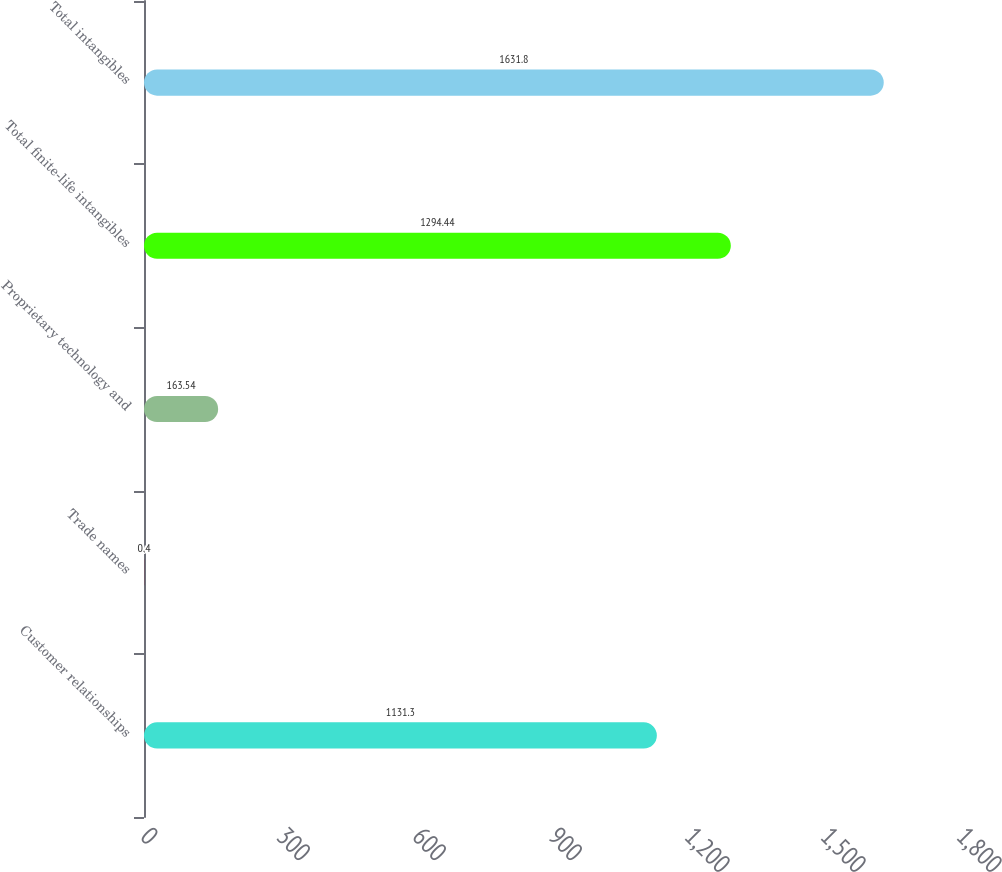<chart> <loc_0><loc_0><loc_500><loc_500><bar_chart><fcel>Customer relationships<fcel>Trade names<fcel>Proprietary technology and<fcel>Total finite-life intangibles<fcel>Total intangibles<nl><fcel>1131.3<fcel>0.4<fcel>163.54<fcel>1294.44<fcel>1631.8<nl></chart> 